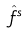Convert formula to latex. <formula><loc_0><loc_0><loc_500><loc_500>\hat { f } ^ { s }</formula> 